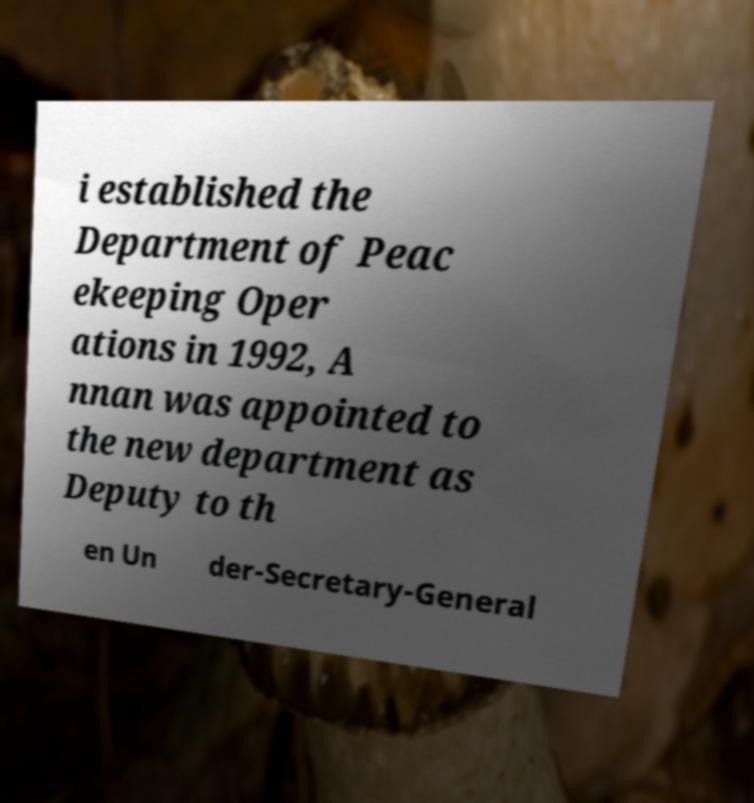There's text embedded in this image that I need extracted. Can you transcribe it verbatim? i established the Department of Peac ekeeping Oper ations in 1992, A nnan was appointed to the new department as Deputy to th en Un der-Secretary-General 